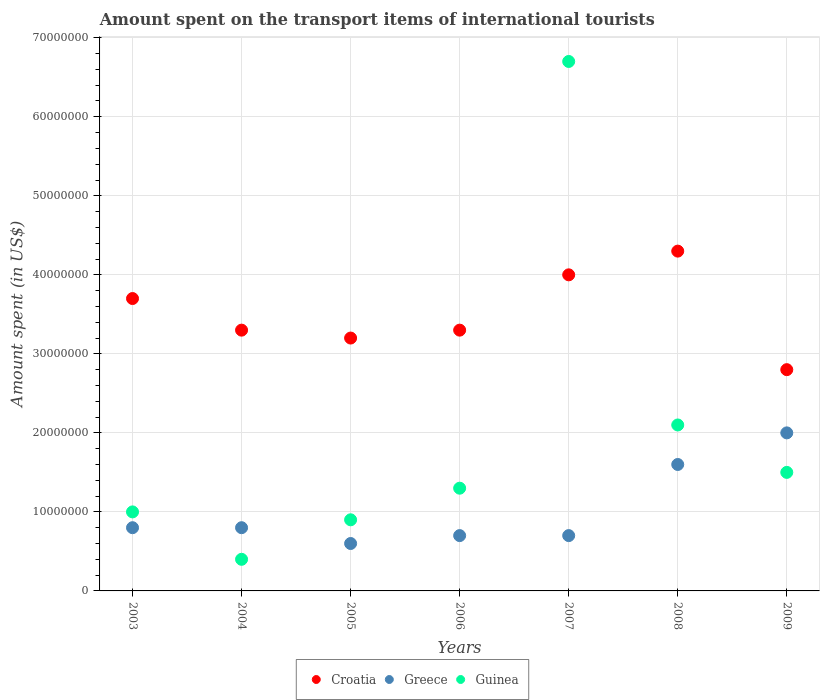Is the number of dotlines equal to the number of legend labels?
Keep it short and to the point. Yes. What is the amount spent on the transport items of international tourists in Croatia in 2008?
Your response must be concise. 4.30e+07. Across all years, what is the maximum amount spent on the transport items of international tourists in Croatia?
Keep it short and to the point. 4.30e+07. Across all years, what is the minimum amount spent on the transport items of international tourists in Croatia?
Ensure brevity in your answer.  2.80e+07. In which year was the amount spent on the transport items of international tourists in Guinea minimum?
Give a very brief answer. 2004. What is the total amount spent on the transport items of international tourists in Croatia in the graph?
Ensure brevity in your answer.  2.46e+08. What is the difference between the amount spent on the transport items of international tourists in Croatia in 2005 and that in 2007?
Give a very brief answer. -8.00e+06. What is the difference between the amount spent on the transport items of international tourists in Guinea in 2004 and the amount spent on the transport items of international tourists in Croatia in 2008?
Your response must be concise. -3.90e+07. What is the average amount spent on the transport items of international tourists in Guinea per year?
Provide a succinct answer. 1.99e+07. In the year 2005, what is the difference between the amount spent on the transport items of international tourists in Croatia and amount spent on the transport items of international tourists in Greece?
Make the answer very short. 2.60e+07. What is the ratio of the amount spent on the transport items of international tourists in Greece in 2004 to that in 2008?
Your answer should be compact. 0.5. Is the difference between the amount spent on the transport items of international tourists in Croatia in 2006 and 2007 greater than the difference between the amount spent on the transport items of international tourists in Greece in 2006 and 2007?
Your answer should be very brief. No. What is the difference between the highest and the second highest amount spent on the transport items of international tourists in Guinea?
Ensure brevity in your answer.  4.60e+07. What is the difference between the highest and the lowest amount spent on the transport items of international tourists in Greece?
Ensure brevity in your answer.  1.40e+07. In how many years, is the amount spent on the transport items of international tourists in Greece greater than the average amount spent on the transport items of international tourists in Greece taken over all years?
Offer a very short reply. 2. Does the amount spent on the transport items of international tourists in Greece monotonically increase over the years?
Give a very brief answer. No. Is the amount spent on the transport items of international tourists in Greece strictly greater than the amount spent on the transport items of international tourists in Guinea over the years?
Give a very brief answer. No. How many years are there in the graph?
Offer a very short reply. 7. How are the legend labels stacked?
Keep it short and to the point. Horizontal. What is the title of the graph?
Your answer should be compact. Amount spent on the transport items of international tourists. Does "Tajikistan" appear as one of the legend labels in the graph?
Your response must be concise. No. What is the label or title of the X-axis?
Keep it short and to the point. Years. What is the label or title of the Y-axis?
Provide a short and direct response. Amount spent (in US$). What is the Amount spent (in US$) in Croatia in 2003?
Your answer should be compact. 3.70e+07. What is the Amount spent (in US$) in Croatia in 2004?
Your answer should be very brief. 3.30e+07. What is the Amount spent (in US$) of Guinea in 2004?
Offer a terse response. 4.00e+06. What is the Amount spent (in US$) of Croatia in 2005?
Provide a short and direct response. 3.20e+07. What is the Amount spent (in US$) in Guinea in 2005?
Your answer should be compact. 9.00e+06. What is the Amount spent (in US$) in Croatia in 2006?
Your answer should be compact. 3.30e+07. What is the Amount spent (in US$) of Greece in 2006?
Provide a succinct answer. 7.00e+06. What is the Amount spent (in US$) in Guinea in 2006?
Keep it short and to the point. 1.30e+07. What is the Amount spent (in US$) of Croatia in 2007?
Offer a very short reply. 4.00e+07. What is the Amount spent (in US$) of Guinea in 2007?
Offer a very short reply. 6.70e+07. What is the Amount spent (in US$) in Croatia in 2008?
Offer a terse response. 4.30e+07. What is the Amount spent (in US$) of Greece in 2008?
Your answer should be very brief. 1.60e+07. What is the Amount spent (in US$) of Guinea in 2008?
Your answer should be compact. 2.10e+07. What is the Amount spent (in US$) of Croatia in 2009?
Your answer should be compact. 2.80e+07. What is the Amount spent (in US$) in Guinea in 2009?
Keep it short and to the point. 1.50e+07. Across all years, what is the maximum Amount spent (in US$) in Croatia?
Your answer should be very brief. 4.30e+07. Across all years, what is the maximum Amount spent (in US$) in Guinea?
Ensure brevity in your answer.  6.70e+07. Across all years, what is the minimum Amount spent (in US$) of Croatia?
Your response must be concise. 2.80e+07. Across all years, what is the minimum Amount spent (in US$) of Greece?
Your response must be concise. 6.00e+06. What is the total Amount spent (in US$) of Croatia in the graph?
Provide a succinct answer. 2.46e+08. What is the total Amount spent (in US$) in Greece in the graph?
Give a very brief answer. 7.20e+07. What is the total Amount spent (in US$) in Guinea in the graph?
Provide a succinct answer. 1.39e+08. What is the difference between the Amount spent (in US$) of Croatia in 2003 and that in 2004?
Offer a terse response. 4.00e+06. What is the difference between the Amount spent (in US$) in Guinea in 2003 and that in 2005?
Offer a very short reply. 1.00e+06. What is the difference between the Amount spent (in US$) of Croatia in 2003 and that in 2006?
Your answer should be very brief. 4.00e+06. What is the difference between the Amount spent (in US$) of Greece in 2003 and that in 2006?
Make the answer very short. 1.00e+06. What is the difference between the Amount spent (in US$) in Greece in 2003 and that in 2007?
Offer a very short reply. 1.00e+06. What is the difference between the Amount spent (in US$) in Guinea in 2003 and that in 2007?
Offer a terse response. -5.70e+07. What is the difference between the Amount spent (in US$) of Croatia in 2003 and that in 2008?
Provide a succinct answer. -6.00e+06. What is the difference between the Amount spent (in US$) in Greece in 2003 and that in 2008?
Provide a succinct answer. -8.00e+06. What is the difference between the Amount spent (in US$) of Guinea in 2003 and that in 2008?
Provide a short and direct response. -1.10e+07. What is the difference between the Amount spent (in US$) of Croatia in 2003 and that in 2009?
Provide a short and direct response. 9.00e+06. What is the difference between the Amount spent (in US$) in Greece in 2003 and that in 2009?
Ensure brevity in your answer.  -1.20e+07. What is the difference between the Amount spent (in US$) in Guinea in 2003 and that in 2009?
Give a very brief answer. -5.00e+06. What is the difference between the Amount spent (in US$) in Greece in 2004 and that in 2005?
Make the answer very short. 2.00e+06. What is the difference between the Amount spent (in US$) of Guinea in 2004 and that in 2005?
Offer a very short reply. -5.00e+06. What is the difference between the Amount spent (in US$) of Croatia in 2004 and that in 2006?
Your response must be concise. 0. What is the difference between the Amount spent (in US$) of Greece in 2004 and that in 2006?
Keep it short and to the point. 1.00e+06. What is the difference between the Amount spent (in US$) in Guinea in 2004 and that in 2006?
Give a very brief answer. -9.00e+06. What is the difference between the Amount spent (in US$) in Croatia in 2004 and that in 2007?
Your answer should be very brief. -7.00e+06. What is the difference between the Amount spent (in US$) in Guinea in 2004 and that in 2007?
Your response must be concise. -6.30e+07. What is the difference between the Amount spent (in US$) of Croatia in 2004 and that in 2008?
Your answer should be very brief. -1.00e+07. What is the difference between the Amount spent (in US$) in Greece in 2004 and that in 2008?
Your answer should be compact. -8.00e+06. What is the difference between the Amount spent (in US$) in Guinea in 2004 and that in 2008?
Offer a terse response. -1.70e+07. What is the difference between the Amount spent (in US$) of Greece in 2004 and that in 2009?
Provide a succinct answer. -1.20e+07. What is the difference between the Amount spent (in US$) of Guinea in 2004 and that in 2009?
Give a very brief answer. -1.10e+07. What is the difference between the Amount spent (in US$) in Greece in 2005 and that in 2006?
Provide a short and direct response. -1.00e+06. What is the difference between the Amount spent (in US$) of Croatia in 2005 and that in 2007?
Keep it short and to the point. -8.00e+06. What is the difference between the Amount spent (in US$) in Greece in 2005 and that in 2007?
Give a very brief answer. -1.00e+06. What is the difference between the Amount spent (in US$) in Guinea in 2005 and that in 2007?
Your answer should be compact. -5.80e+07. What is the difference between the Amount spent (in US$) in Croatia in 2005 and that in 2008?
Your answer should be very brief. -1.10e+07. What is the difference between the Amount spent (in US$) in Greece in 2005 and that in 2008?
Provide a short and direct response. -1.00e+07. What is the difference between the Amount spent (in US$) of Guinea in 2005 and that in 2008?
Your response must be concise. -1.20e+07. What is the difference between the Amount spent (in US$) of Croatia in 2005 and that in 2009?
Provide a succinct answer. 4.00e+06. What is the difference between the Amount spent (in US$) in Greece in 2005 and that in 2009?
Provide a succinct answer. -1.40e+07. What is the difference between the Amount spent (in US$) of Guinea in 2005 and that in 2009?
Ensure brevity in your answer.  -6.00e+06. What is the difference between the Amount spent (in US$) of Croatia in 2006 and that in 2007?
Your answer should be compact. -7.00e+06. What is the difference between the Amount spent (in US$) in Guinea in 2006 and that in 2007?
Your response must be concise. -5.40e+07. What is the difference between the Amount spent (in US$) in Croatia in 2006 and that in 2008?
Your answer should be compact. -1.00e+07. What is the difference between the Amount spent (in US$) in Greece in 2006 and that in 2008?
Your answer should be very brief. -9.00e+06. What is the difference between the Amount spent (in US$) in Guinea in 2006 and that in 2008?
Your response must be concise. -8.00e+06. What is the difference between the Amount spent (in US$) of Croatia in 2006 and that in 2009?
Your answer should be compact. 5.00e+06. What is the difference between the Amount spent (in US$) in Greece in 2006 and that in 2009?
Keep it short and to the point. -1.30e+07. What is the difference between the Amount spent (in US$) in Guinea in 2006 and that in 2009?
Ensure brevity in your answer.  -2.00e+06. What is the difference between the Amount spent (in US$) in Croatia in 2007 and that in 2008?
Ensure brevity in your answer.  -3.00e+06. What is the difference between the Amount spent (in US$) in Greece in 2007 and that in 2008?
Keep it short and to the point. -9.00e+06. What is the difference between the Amount spent (in US$) of Guinea in 2007 and that in 2008?
Your response must be concise. 4.60e+07. What is the difference between the Amount spent (in US$) of Greece in 2007 and that in 2009?
Offer a very short reply. -1.30e+07. What is the difference between the Amount spent (in US$) in Guinea in 2007 and that in 2009?
Make the answer very short. 5.20e+07. What is the difference between the Amount spent (in US$) in Croatia in 2008 and that in 2009?
Ensure brevity in your answer.  1.50e+07. What is the difference between the Amount spent (in US$) of Greece in 2008 and that in 2009?
Provide a succinct answer. -4.00e+06. What is the difference between the Amount spent (in US$) in Croatia in 2003 and the Amount spent (in US$) in Greece in 2004?
Your response must be concise. 2.90e+07. What is the difference between the Amount spent (in US$) of Croatia in 2003 and the Amount spent (in US$) of Guinea in 2004?
Provide a succinct answer. 3.30e+07. What is the difference between the Amount spent (in US$) in Croatia in 2003 and the Amount spent (in US$) in Greece in 2005?
Make the answer very short. 3.10e+07. What is the difference between the Amount spent (in US$) of Croatia in 2003 and the Amount spent (in US$) of Guinea in 2005?
Make the answer very short. 2.80e+07. What is the difference between the Amount spent (in US$) of Croatia in 2003 and the Amount spent (in US$) of Greece in 2006?
Provide a succinct answer. 3.00e+07. What is the difference between the Amount spent (in US$) in Croatia in 2003 and the Amount spent (in US$) in Guinea in 2006?
Give a very brief answer. 2.40e+07. What is the difference between the Amount spent (in US$) of Greece in 2003 and the Amount spent (in US$) of Guinea in 2006?
Offer a very short reply. -5.00e+06. What is the difference between the Amount spent (in US$) of Croatia in 2003 and the Amount spent (in US$) of Greece in 2007?
Your answer should be very brief. 3.00e+07. What is the difference between the Amount spent (in US$) of Croatia in 2003 and the Amount spent (in US$) of Guinea in 2007?
Provide a short and direct response. -3.00e+07. What is the difference between the Amount spent (in US$) in Greece in 2003 and the Amount spent (in US$) in Guinea in 2007?
Keep it short and to the point. -5.90e+07. What is the difference between the Amount spent (in US$) of Croatia in 2003 and the Amount spent (in US$) of Greece in 2008?
Your response must be concise. 2.10e+07. What is the difference between the Amount spent (in US$) of Croatia in 2003 and the Amount spent (in US$) of Guinea in 2008?
Your answer should be compact. 1.60e+07. What is the difference between the Amount spent (in US$) of Greece in 2003 and the Amount spent (in US$) of Guinea in 2008?
Offer a very short reply. -1.30e+07. What is the difference between the Amount spent (in US$) of Croatia in 2003 and the Amount spent (in US$) of Greece in 2009?
Give a very brief answer. 1.70e+07. What is the difference between the Amount spent (in US$) of Croatia in 2003 and the Amount spent (in US$) of Guinea in 2009?
Your answer should be compact. 2.20e+07. What is the difference between the Amount spent (in US$) in Greece in 2003 and the Amount spent (in US$) in Guinea in 2009?
Give a very brief answer. -7.00e+06. What is the difference between the Amount spent (in US$) in Croatia in 2004 and the Amount spent (in US$) in Greece in 2005?
Give a very brief answer. 2.70e+07. What is the difference between the Amount spent (in US$) of Croatia in 2004 and the Amount spent (in US$) of Guinea in 2005?
Your response must be concise. 2.40e+07. What is the difference between the Amount spent (in US$) of Greece in 2004 and the Amount spent (in US$) of Guinea in 2005?
Offer a very short reply. -1.00e+06. What is the difference between the Amount spent (in US$) in Croatia in 2004 and the Amount spent (in US$) in Greece in 2006?
Provide a short and direct response. 2.60e+07. What is the difference between the Amount spent (in US$) in Greece in 2004 and the Amount spent (in US$) in Guinea in 2006?
Make the answer very short. -5.00e+06. What is the difference between the Amount spent (in US$) of Croatia in 2004 and the Amount spent (in US$) of Greece in 2007?
Your response must be concise. 2.60e+07. What is the difference between the Amount spent (in US$) of Croatia in 2004 and the Amount spent (in US$) of Guinea in 2007?
Keep it short and to the point. -3.40e+07. What is the difference between the Amount spent (in US$) of Greece in 2004 and the Amount spent (in US$) of Guinea in 2007?
Offer a terse response. -5.90e+07. What is the difference between the Amount spent (in US$) in Croatia in 2004 and the Amount spent (in US$) in Greece in 2008?
Give a very brief answer. 1.70e+07. What is the difference between the Amount spent (in US$) of Croatia in 2004 and the Amount spent (in US$) of Guinea in 2008?
Your answer should be very brief. 1.20e+07. What is the difference between the Amount spent (in US$) in Greece in 2004 and the Amount spent (in US$) in Guinea in 2008?
Make the answer very short. -1.30e+07. What is the difference between the Amount spent (in US$) of Croatia in 2004 and the Amount spent (in US$) of Greece in 2009?
Your response must be concise. 1.30e+07. What is the difference between the Amount spent (in US$) of Croatia in 2004 and the Amount spent (in US$) of Guinea in 2009?
Your response must be concise. 1.80e+07. What is the difference between the Amount spent (in US$) in Greece in 2004 and the Amount spent (in US$) in Guinea in 2009?
Make the answer very short. -7.00e+06. What is the difference between the Amount spent (in US$) of Croatia in 2005 and the Amount spent (in US$) of Greece in 2006?
Your response must be concise. 2.50e+07. What is the difference between the Amount spent (in US$) of Croatia in 2005 and the Amount spent (in US$) of Guinea in 2006?
Offer a terse response. 1.90e+07. What is the difference between the Amount spent (in US$) of Greece in 2005 and the Amount spent (in US$) of Guinea in 2006?
Your answer should be very brief. -7.00e+06. What is the difference between the Amount spent (in US$) in Croatia in 2005 and the Amount spent (in US$) in Greece in 2007?
Keep it short and to the point. 2.50e+07. What is the difference between the Amount spent (in US$) in Croatia in 2005 and the Amount spent (in US$) in Guinea in 2007?
Give a very brief answer. -3.50e+07. What is the difference between the Amount spent (in US$) in Greece in 2005 and the Amount spent (in US$) in Guinea in 2007?
Provide a short and direct response. -6.10e+07. What is the difference between the Amount spent (in US$) in Croatia in 2005 and the Amount spent (in US$) in Greece in 2008?
Provide a short and direct response. 1.60e+07. What is the difference between the Amount spent (in US$) of Croatia in 2005 and the Amount spent (in US$) of Guinea in 2008?
Give a very brief answer. 1.10e+07. What is the difference between the Amount spent (in US$) in Greece in 2005 and the Amount spent (in US$) in Guinea in 2008?
Provide a short and direct response. -1.50e+07. What is the difference between the Amount spent (in US$) in Croatia in 2005 and the Amount spent (in US$) in Guinea in 2009?
Offer a terse response. 1.70e+07. What is the difference between the Amount spent (in US$) in Greece in 2005 and the Amount spent (in US$) in Guinea in 2009?
Provide a short and direct response. -9.00e+06. What is the difference between the Amount spent (in US$) of Croatia in 2006 and the Amount spent (in US$) of Greece in 2007?
Offer a very short reply. 2.60e+07. What is the difference between the Amount spent (in US$) of Croatia in 2006 and the Amount spent (in US$) of Guinea in 2007?
Keep it short and to the point. -3.40e+07. What is the difference between the Amount spent (in US$) in Greece in 2006 and the Amount spent (in US$) in Guinea in 2007?
Your answer should be very brief. -6.00e+07. What is the difference between the Amount spent (in US$) in Croatia in 2006 and the Amount spent (in US$) in Greece in 2008?
Keep it short and to the point. 1.70e+07. What is the difference between the Amount spent (in US$) of Croatia in 2006 and the Amount spent (in US$) of Guinea in 2008?
Give a very brief answer. 1.20e+07. What is the difference between the Amount spent (in US$) of Greece in 2006 and the Amount spent (in US$) of Guinea in 2008?
Your answer should be compact. -1.40e+07. What is the difference between the Amount spent (in US$) in Croatia in 2006 and the Amount spent (in US$) in Greece in 2009?
Your response must be concise. 1.30e+07. What is the difference between the Amount spent (in US$) in Croatia in 2006 and the Amount spent (in US$) in Guinea in 2009?
Provide a succinct answer. 1.80e+07. What is the difference between the Amount spent (in US$) of Greece in 2006 and the Amount spent (in US$) of Guinea in 2009?
Your answer should be compact. -8.00e+06. What is the difference between the Amount spent (in US$) of Croatia in 2007 and the Amount spent (in US$) of Greece in 2008?
Provide a succinct answer. 2.40e+07. What is the difference between the Amount spent (in US$) of Croatia in 2007 and the Amount spent (in US$) of Guinea in 2008?
Your answer should be very brief. 1.90e+07. What is the difference between the Amount spent (in US$) in Greece in 2007 and the Amount spent (in US$) in Guinea in 2008?
Make the answer very short. -1.40e+07. What is the difference between the Amount spent (in US$) of Croatia in 2007 and the Amount spent (in US$) of Greece in 2009?
Your answer should be very brief. 2.00e+07. What is the difference between the Amount spent (in US$) of Croatia in 2007 and the Amount spent (in US$) of Guinea in 2009?
Your response must be concise. 2.50e+07. What is the difference between the Amount spent (in US$) in Greece in 2007 and the Amount spent (in US$) in Guinea in 2009?
Your answer should be very brief. -8.00e+06. What is the difference between the Amount spent (in US$) of Croatia in 2008 and the Amount spent (in US$) of Greece in 2009?
Provide a succinct answer. 2.30e+07. What is the difference between the Amount spent (in US$) of Croatia in 2008 and the Amount spent (in US$) of Guinea in 2009?
Keep it short and to the point. 2.80e+07. What is the difference between the Amount spent (in US$) in Greece in 2008 and the Amount spent (in US$) in Guinea in 2009?
Keep it short and to the point. 1.00e+06. What is the average Amount spent (in US$) of Croatia per year?
Your answer should be very brief. 3.51e+07. What is the average Amount spent (in US$) in Greece per year?
Keep it short and to the point. 1.03e+07. What is the average Amount spent (in US$) in Guinea per year?
Your answer should be very brief. 1.99e+07. In the year 2003, what is the difference between the Amount spent (in US$) in Croatia and Amount spent (in US$) in Greece?
Your answer should be very brief. 2.90e+07. In the year 2003, what is the difference between the Amount spent (in US$) of Croatia and Amount spent (in US$) of Guinea?
Provide a succinct answer. 2.70e+07. In the year 2004, what is the difference between the Amount spent (in US$) of Croatia and Amount spent (in US$) of Greece?
Keep it short and to the point. 2.50e+07. In the year 2004, what is the difference between the Amount spent (in US$) of Croatia and Amount spent (in US$) of Guinea?
Offer a terse response. 2.90e+07. In the year 2005, what is the difference between the Amount spent (in US$) of Croatia and Amount spent (in US$) of Greece?
Your response must be concise. 2.60e+07. In the year 2005, what is the difference between the Amount spent (in US$) in Croatia and Amount spent (in US$) in Guinea?
Provide a short and direct response. 2.30e+07. In the year 2005, what is the difference between the Amount spent (in US$) of Greece and Amount spent (in US$) of Guinea?
Give a very brief answer. -3.00e+06. In the year 2006, what is the difference between the Amount spent (in US$) of Croatia and Amount spent (in US$) of Greece?
Ensure brevity in your answer.  2.60e+07. In the year 2006, what is the difference between the Amount spent (in US$) of Greece and Amount spent (in US$) of Guinea?
Provide a succinct answer. -6.00e+06. In the year 2007, what is the difference between the Amount spent (in US$) of Croatia and Amount spent (in US$) of Greece?
Your response must be concise. 3.30e+07. In the year 2007, what is the difference between the Amount spent (in US$) in Croatia and Amount spent (in US$) in Guinea?
Provide a succinct answer. -2.70e+07. In the year 2007, what is the difference between the Amount spent (in US$) of Greece and Amount spent (in US$) of Guinea?
Offer a terse response. -6.00e+07. In the year 2008, what is the difference between the Amount spent (in US$) in Croatia and Amount spent (in US$) in Greece?
Provide a succinct answer. 2.70e+07. In the year 2008, what is the difference between the Amount spent (in US$) in Croatia and Amount spent (in US$) in Guinea?
Offer a very short reply. 2.20e+07. In the year 2008, what is the difference between the Amount spent (in US$) of Greece and Amount spent (in US$) of Guinea?
Give a very brief answer. -5.00e+06. In the year 2009, what is the difference between the Amount spent (in US$) in Croatia and Amount spent (in US$) in Greece?
Provide a succinct answer. 8.00e+06. In the year 2009, what is the difference between the Amount spent (in US$) in Croatia and Amount spent (in US$) in Guinea?
Keep it short and to the point. 1.30e+07. What is the ratio of the Amount spent (in US$) of Croatia in 2003 to that in 2004?
Give a very brief answer. 1.12. What is the ratio of the Amount spent (in US$) of Guinea in 2003 to that in 2004?
Provide a short and direct response. 2.5. What is the ratio of the Amount spent (in US$) in Croatia in 2003 to that in 2005?
Your answer should be very brief. 1.16. What is the ratio of the Amount spent (in US$) of Guinea in 2003 to that in 2005?
Keep it short and to the point. 1.11. What is the ratio of the Amount spent (in US$) in Croatia in 2003 to that in 2006?
Offer a terse response. 1.12. What is the ratio of the Amount spent (in US$) of Greece in 2003 to that in 2006?
Your answer should be compact. 1.14. What is the ratio of the Amount spent (in US$) of Guinea in 2003 to that in 2006?
Your answer should be compact. 0.77. What is the ratio of the Amount spent (in US$) in Croatia in 2003 to that in 2007?
Offer a very short reply. 0.93. What is the ratio of the Amount spent (in US$) in Greece in 2003 to that in 2007?
Offer a very short reply. 1.14. What is the ratio of the Amount spent (in US$) in Guinea in 2003 to that in 2007?
Offer a very short reply. 0.15. What is the ratio of the Amount spent (in US$) of Croatia in 2003 to that in 2008?
Your answer should be very brief. 0.86. What is the ratio of the Amount spent (in US$) in Greece in 2003 to that in 2008?
Your response must be concise. 0.5. What is the ratio of the Amount spent (in US$) of Guinea in 2003 to that in 2008?
Your answer should be compact. 0.48. What is the ratio of the Amount spent (in US$) in Croatia in 2003 to that in 2009?
Offer a terse response. 1.32. What is the ratio of the Amount spent (in US$) in Guinea in 2003 to that in 2009?
Give a very brief answer. 0.67. What is the ratio of the Amount spent (in US$) in Croatia in 2004 to that in 2005?
Your response must be concise. 1.03. What is the ratio of the Amount spent (in US$) of Greece in 2004 to that in 2005?
Give a very brief answer. 1.33. What is the ratio of the Amount spent (in US$) in Guinea in 2004 to that in 2005?
Your answer should be very brief. 0.44. What is the ratio of the Amount spent (in US$) of Greece in 2004 to that in 2006?
Ensure brevity in your answer.  1.14. What is the ratio of the Amount spent (in US$) of Guinea in 2004 to that in 2006?
Your answer should be very brief. 0.31. What is the ratio of the Amount spent (in US$) in Croatia in 2004 to that in 2007?
Your answer should be very brief. 0.82. What is the ratio of the Amount spent (in US$) in Greece in 2004 to that in 2007?
Give a very brief answer. 1.14. What is the ratio of the Amount spent (in US$) in Guinea in 2004 to that in 2007?
Provide a succinct answer. 0.06. What is the ratio of the Amount spent (in US$) of Croatia in 2004 to that in 2008?
Offer a terse response. 0.77. What is the ratio of the Amount spent (in US$) in Greece in 2004 to that in 2008?
Provide a short and direct response. 0.5. What is the ratio of the Amount spent (in US$) in Guinea in 2004 to that in 2008?
Your answer should be very brief. 0.19. What is the ratio of the Amount spent (in US$) of Croatia in 2004 to that in 2009?
Give a very brief answer. 1.18. What is the ratio of the Amount spent (in US$) in Guinea in 2004 to that in 2009?
Your answer should be very brief. 0.27. What is the ratio of the Amount spent (in US$) of Croatia in 2005 to that in 2006?
Provide a succinct answer. 0.97. What is the ratio of the Amount spent (in US$) of Guinea in 2005 to that in 2006?
Make the answer very short. 0.69. What is the ratio of the Amount spent (in US$) in Greece in 2005 to that in 2007?
Offer a very short reply. 0.86. What is the ratio of the Amount spent (in US$) of Guinea in 2005 to that in 2007?
Ensure brevity in your answer.  0.13. What is the ratio of the Amount spent (in US$) in Croatia in 2005 to that in 2008?
Give a very brief answer. 0.74. What is the ratio of the Amount spent (in US$) in Guinea in 2005 to that in 2008?
Your response must be concise. 0.43. What is the ratio of the Amount spent (in US$) of Croatia in 2005 to that in 2009?
Your response must be concise. 1.14. What is the ratio of the Amount spent (in US$) of Guinea in 2005 to that in 2009?
Your response must be concise. 0.6. What is the ratio of the Amount spent (in US$) in Croatia in 2006 to that in 2007?
Your answer should be compact. 0.82. What is the ratio of the Amount spent (in US$) of Greece in 2006 to that in 2007?
Your response must be concise. 1. What is the ratio of the Amount spent (in US$) in Guinea in 2006 to that in 2007?
Provide a short and direct response. 0.19. What is the ratio of the Amount spent (in US$) of Croatia in 2006 to that in 2008?
Your response must be concise. 0.77. What is the ratio of the Amount spent (in US$) in Greece in 2006 to that in 2008?
Offer a terse response. 0.44. What is the ratio of the Amount spent (in US$) in Guinea in 2006 to that in 2008?
Offer a terse response. 0.62. What is the ratio of the Amount spent (in US$) of Croatia in 2006 to that in 2009?
Provide a succinct answer. 1.18. What is the ratio of the Amount spent (in US$) in Greece in 2006 to that in 2009?
Ensure brevity in your answer.  0.35. What is the ratio of the Amount spent (in US$) in Guinea in 2006 to that in 2009?
Give a very brief answer. 0.87. What is the ratio of the Amount spent (in US$) of Croatia in 2007 to that in 2008?
Offer a very short reply. 0.93. What is the ratio of the Amount spent (in US$) of Greece in 2007 to that in 2008?
Offer a very short reply. 0.44. What is the ratio of the Amount spent (in US$) of Guinea in 2007 to that in 2008?
Provide a short and direct response. 3.19. What is the ratio of the Amount spent (in US$) of Croatia in 2007 to that in 2009?
Your answer should be very brief. 1.43. What is the ratio of the Amount spent (in US$) in Greece in 2007 to that in 2009?
Provide a succinct answer. 0.35. What is the ratio of the Amount spent (in US$) in Guinea in 2007 to that in 2009?
Give a very brief answer. 4.47. What is the ratio of the Amount spent (in US$) of Croatia in 2008 to that in 2009?
Offer a very short reply. 1.54. What is the ratio of the Amount spent (in US$) in Greece in 2008 to that in 2009?
Keep it short and to the point. 0.8. What is the difference between the highest and the second highest Amount spent (in US$) of Greece?
Your answer should be very brief. 4.00e+06. What is the difference between the highest and the second highest Amount spent (in US$) in Guinea?
Offer a terse response. 4.60e+07. What is the difference between the highest and the lowest Amount spent (in US$) in Croatia?
Your answer should be very brief. 1.50e+07. What is the difference between the highest and the lowest Amount spent (in US$) in Greece?
Provide a short and direct response. 1.40e+07. What is the difference between the highest and the lowest Amount spent (in US$) in Guinea?
Offer a very short reply. 6.30e+07. 